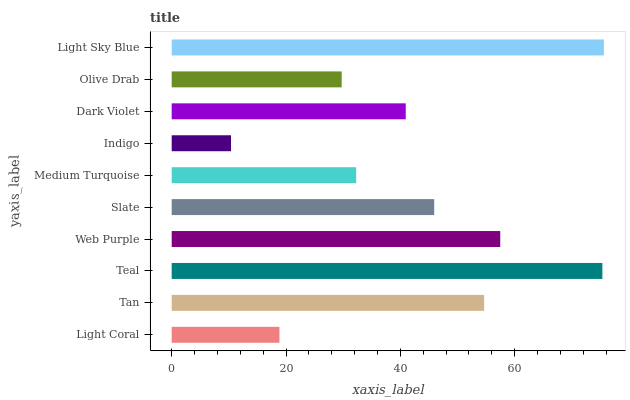Is Indigo the minimum?
Answer yes or no. Yes. Is Light Sky Blue the maximum?
Answer yes or no. Yes. Is Tan the minimum?
Answer yes or no. No. Is Tan the maximum?
Answer yes or no. No. Is Tan greater than Light Coral?
Answer yes or no. Yes. Is Light Coral less than Tan?
Answer yes or no. Yes. Is Light Coral greater than Tan?
Answer yes or no. No. Is Tan less than Light Coral?
Answer yes or no. No. Is Slate the high median?
Answer yes or no. Yes. Is Dark Violet the low median?
Answer yes or no. Yes. Is Web Purple the high median?
Answer yes or no. No. Is Web Purple the low median?
Answer yes or no. No. 